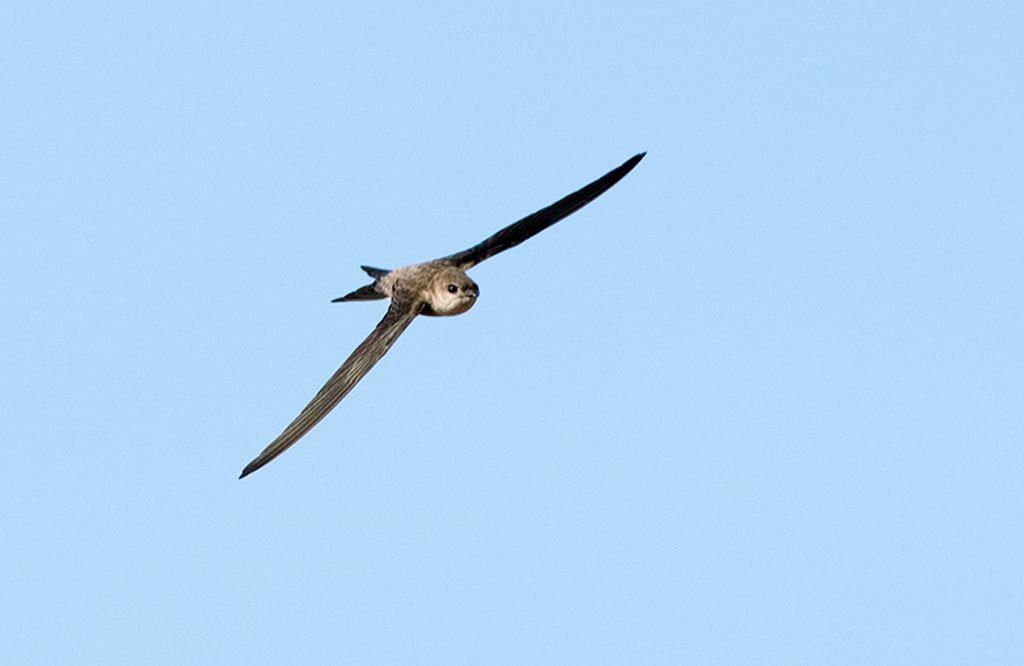What type of animal can be seen in the image? There is a bird in the image. What is the bird doing in the image? The bird is flying. What can be seen in the background of the image? The sky is visible in the background of the image. What is the color of the sky in the image? The sky is clear and blue in the image. What type of wax can be seen melting on the bird's teeth in the image? There is no wax or teeth present on the bird in the image. 